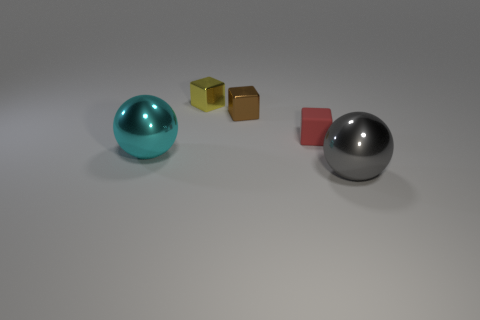Add 5 cyan shiny spheres. How many objects exist? 10 Subtract all small brown cubes. How many cubes are left? 2 Subtract 1 blocks. How many blocks are left? 2 Subtract all gray metal cylinders. Subtract all tiny yellow objects. How many objects are left? 4 Add 1 big balls. How many big balls are left? 3 Add 3 yellow metal objects. How many yellow metal objects exist? 4 Subtract 0 purple balls. How many objects are left? 5 Subtract all cubes. How many objects are left? 2 Subtract all purple cubes. Subtract all purple balls. How many cubes are left? 3 